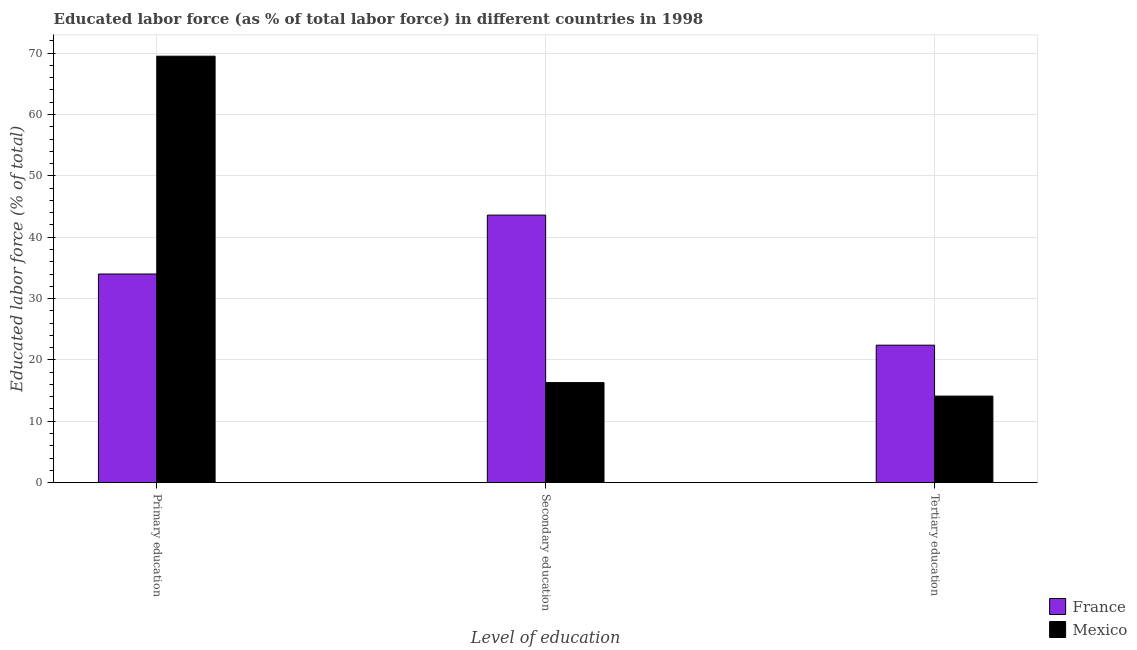How many different coloured bars are there?
Provide a succinct answer. 2. How many groups of bars are there?
Offer a terse response. 3. Are the number of bars on each tick of the X-axis equal?
Your answer should be compact. Yes. How many bars are there on the 2nd tick from the right?
Give a very brief answer. 2. What is the percentage of labor force who received secondary education in France?
Ensure brevity in your answer.  43.6. Across all countries, what is the maximum percentage of labor force who received primary education?
Provide a succinct answer. 69.5. Across all countries, what is the minimum percentage of labor force who received secondary education?
Your response must be concise. 16.3. What is the total percentage of labor force who received primary education in the graph?
Ensure brevity in your answer.  103.5. What is the difference between the percentage of labor force who received secondary education in France and that in Mexico?
Your response must be concise. 27.3. What is the difference between the percentage of labor force who received tertiary education in Mexico and the percentage of labor force who received secondary education in France?
Your response must be concise. -29.5. What is the average percentage of labor force who received tertiary education per country?
Provide a short and direct response. 18.25. What is the difference between the percentage of labor force who received secondary education and percentage of labor force who received tertiary education in Mexico?
Your answer should be very brief. 2.2. What is the ratio of the percentage of labor force who received primary education in France to that in Mexico?
Your answer should be very brief. 0.49. Is the percentage of labor force who received secondary education in Mexico less than that in France?
Provide a succinct answer. Yes. Is the difference between the percentage of labor force who received tertiary education in Mexico and France greater than the difference between the percentage of labor force who received primary education in Mexico and France?
Ensure brevity in your answer.  No. What is the difference between the highest and the second highest percentage of labor force who received tertiary education?
Provide a short and direct response. 8.3. What is the difference between the highest and the lowest percentage of labor force who received tertiary education?
Make the answer very short. 8.3. What does the 2nd bar from the right in Tertiary education represents?
Offer a terse response. France. Is it the case that in every country, the sum of the percentage of labor force who received primary education and percentage of labor force who received secondary education is greater than the percentage of labor force who received tertiary education?
Provide a short and direct response. Yes. How many bars are there?
Offer a very short reply. 6. How many countries are there in the graph?
Keep it short and to the point. 2. What is the difference between two consecutive major ticks on the Y-axis?
Your answer should be compact. 10. Does the graph contain any zero values?
Your response must be concise. No. Does the graph contain grids?
Keep it short and to the point. Yes. Where does the legend appear in the graph?
Provide a succinct answer. Bottom right. How many legend labels are there?
Give a very brief answer. 2. How are the legend labels stacked?
Keep it short and to the point. Vertical. What is the title of the graph?
Make the answer very short. Educated labor force (as % of total labor force) in different countries in 1998. Does "East Asia (all income levels)" appear as one of the legend labels in the graph?
Your response must be concise. No. What is the label or title of the X-axis?
Offer a terse response. Level of education. What is the label or title of the Y-axis?
Keep it short and to the point. Educated labor force (% of total). What is the Educated labor force (% of total) of Mexico in Primary education?
Make the answer very short. 69.5. What is the Educated labor force (% of total) of France in Secondary education?
Provide a succinct answer. 43.6. What is the Educated labor force (% of total) in Mexico in Secondary education?
Provide a short and direct response. 16.3. What is the Educated labor force (% of total) of France in Tertiary education?
Offer a terse response. 22.4. What is the Educated labor force (% of total) of Mexico in Tertiary education?
Make the answer very short. 14.1. Across all Level of education, what is the maximum Educated labor force (% of total) of France?
Keep it short and to the point. 43.6. Across all Level of education, what is the maximum Educated labor force (% of total) of Mexico?
Ensure brevity in your answer.  69.5. Across all Level of education, what is the minimum Educated labor force (% of total) of France?
Make the answer very short. 22.4. Across all Level of education, what is the minimum Educated labor force (% of total) in Mexico?
Your answer should be compact. 14.1. What is the total Educated labor force (% of total) in France in the graph?
Make the answer very short. 100. What is the total Educated labor force (% of total) of Mexico in the graph?
Make the answer very short. 99.9. What is the difference between the Educated labor force (% of total) of Mexico in Primary education and that in Secondary education?
Make the answer very short. 53.2. What is the difference between the Educated labor force (% of total) in Mexico in Primary education and that in Tertiary education?
Your answer should be compact. 55.4. What is the difference between the Educated labor force (% of total) of France in Secondary education and that in Tertiary education?
Provide a succinct answer. 21.2. What is the difference between the Educated labor force (% of total) in Mexico in Secondary education and that in Tertiary education?
Provide a succinct answer. 2.2. What is the difference between the Educated labor force (% of total) of France in Primary education and the Educated labor force (% of total) of Mexico in Secondary education?
Your answer should be compact. 17.7. What is the difference between the Educated labor force (% of total) of France in Secondary education and the Educated labor force (% of total) of Mexico in Tertiary education?
Keep it short and to the point. 29.5. What is the average Educated labor force (% of total) in France per Level of education?
Your response must be concise. 33.33. What is the average Educated labor force (% of total) of Mexico per Level of education?
Provide a succinct answer. 33.3. What is the difference between the Educated labor force (% of total) in France and Educated labor force (% of total) in Mexico in Primary education?
Ensure brevity in your answer.  -35.5. What is the difference between the Educated labor force (% of total) in France and Educated labor force (% of total) in Mexico in Secondary education?
Provide a succinct answer. 27.3. What is the ratio of the Educated labor force (% of total) of France in Primary education to that in Secondary education?
Give a very brief answer. 0.78. What is the ratio of the Educated labor force (% of total) in Mexico in Primary education to that in Secondary education?
Ensure brevity in your answer.  4.26. What is the ratio of the Educated labor force (% of total) in France in Primary education to that in Tertiary education?
Your answer should be very brief. 1.52. What is the ratio of the Educated labor force (% of total) of Mexico in Primary education to that in Tertiary education?
Provide a short and direct response. 4.93. What is the ratio of the Educated labor force (% of total) of France in Secondary education to that in Tertiary education?
Ensure brevity in your answer.  1.95. What is the ratio of the Educated labor force (% of total) in Mexico in Secondary education to that in Tertiary education?
Keep it short and to the point. 1.16. What is the difference between the highest and the second highest Educated labor force (% of total) in France?
Provide a short and direct response. 9.6. What is the difference between the highest and the second highest Educated labor force (% of total) in Mexico?
Ensure brevity in your answer.  53.2. What is the difference between the highest and the lowest Educated labor force (% of total) in France?
Your answer should be compact. 21.2. What is the difference between the highest and the lowest Educated labor force (% of total) of Mexico?
Ensure brevity in your answer.  55.4. 